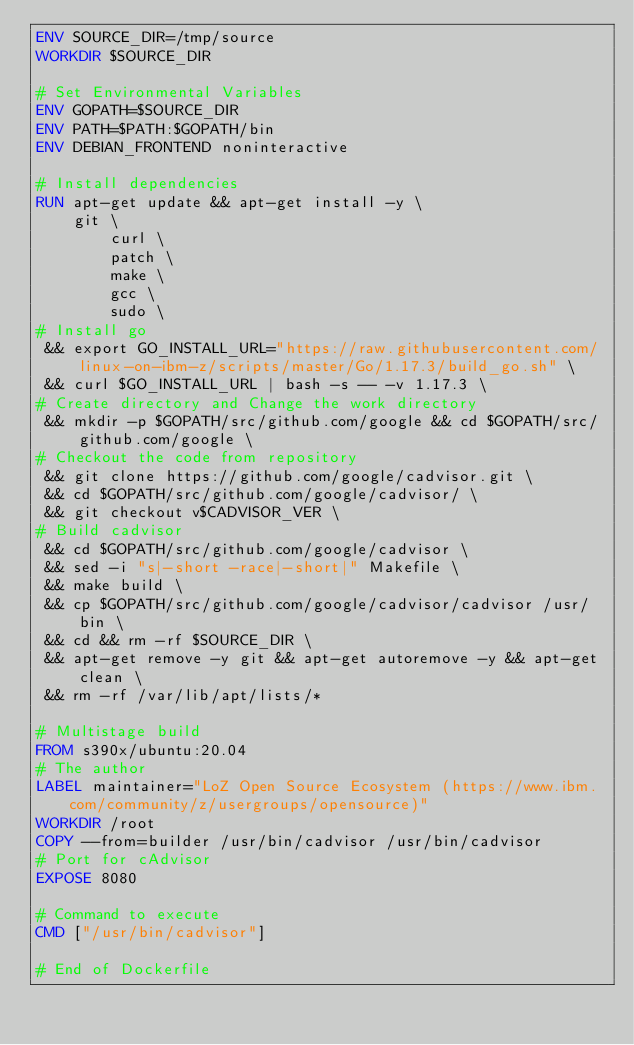Convert code to text. <code><loc_0><loc_0><loc_500><loc_500><_Dockerfile_>ENV SOURCE_DIR=/tmp/source
WORKDIR $SOURCE_DIR

# Set Environmental Variables
ENV GOPATH=$SOURCE_DIR
ENV PATH=$PATH:$GOPATH/bin
ENV DEBIAN_FRONTEND noninteractive

# Install dependencies
RUN apt-get update && apt-get install -y \
    git \
        curl \
        patch \
        make \
        gcc \
        sudo \
# Install go
 && export GO_INSTALL_URL="https://raw.githubusercontent.com/linux-on-ibm-z/scripts/master/Go/1.17.3/build_go.sh" \
 && curl $GO_INSTALL_URL | bash -s -- -v 1.17.3 \
# Create directory and Change the work directory
 && mkdir -p $GOPATH/src/github.com/google && cd $GOPATH/src/github.com/google \
# Checkout the code from repository
 && git clone https://github.com/google/cadvisor.git \
 && cd $GOPATH/src/github.com/google/cadvisor/ \
 && git checkout v$CADVISOR_VER \
# Build cadvisor
 && cd $GOPATH/src/github.com/google/cadvisor \
 && sed -i "s|-short -race|-short|" Makefile \
 && make build \
 && cp $GOPATH/src/github.com/google/cadvisor/cadvisor /usr/bin \
 && cd && rm -rf $SOURCE_DIR \
 && apt-get remove -y git && apt-get autoremove -y && apt-get clean \
 && rm -rf /var/lib/apt/lists/*

# Multistage build
FROM s390x/ubuntu:20.04
# The author
LABEL maintainer="LoZ Open Source Ecosystem (https://www.ibm.com/community/z/usergroups/opensource)"
WORKDIR /root
COPY --from=builder /usr/bin/cadvisor /usr/bin/cadvisor
# Port for cAdvisor
EXPOSE 8080

# Command to execute
CMD ["/usr/bin/cadvisor"]

# End of Dockerfile

</code> 